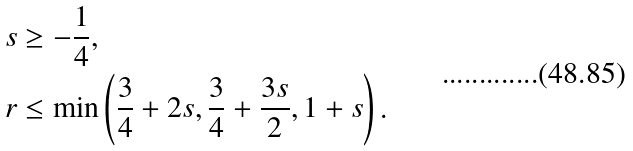Convert formula to latex. <formula><loc_0><loc_0><loc_500><loc_500>s & \geq - \frac { 1 } { 4 } , \\ r & \leq \min \left ( \frac { 3 } { 4 } + 2 s , \frac { 3 } { 4 } + \frac { 3 s } { 2 } , 1 + s \right ) .</formula> 